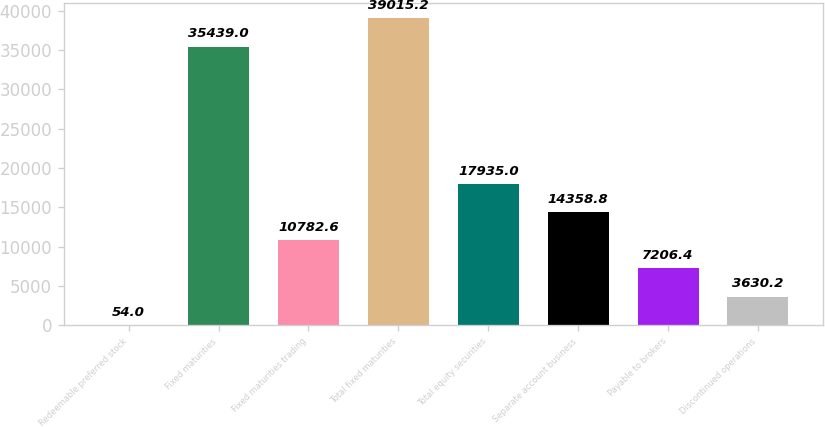Convert chart to OTSL. <chart><loc_0><loc_0><loc_500><loc_500><bar_chart><fcel>Redeemable preferred stock<fcel>Fixed maturities<fcel>Fixed maturities trading<fcel>Total fixed maturities<fcel>Total equity securities<fcel>Separate account business<fcel>Payable to brokers<fcel>Discontinued operations<nl><fcel>54<fcel>35439<fcel>10782.6<fcel>39015.2<fcel>17935<fcel>14358.8<fcel>7206.4<fcel>3630.2<nl></chart> 